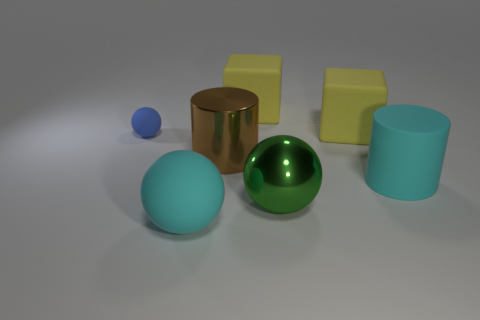The sphere that is right of the big cyan rubber thing in front of the large cyan matte cylinder is made of what material?
Your response must be concise. Metal. Is the green ball the same size as the cyan rubber sphere?
Ensure brevity in your answer.  Yes. How many objects are either large matte objects or matte spheres?
Keep it short and to the point. 5. There is a rubber object that is in front of the small blue rubber ball and on the right side of the large cyan ball; how big is it?
Ensure brevity in your answer.  Large. Is the number of big brown objects that are on the right side of the big metal ball less than the number of big cyan spheres?
Provide a short and direct response. Yes. What is the shape of the blue object that is the same material as the cyan cylinder?
Offer a terse response. Sphere. There is a metallic object that is on the right side of the brown thing; is it the same shape as the thing that is left of the cyan matte sphere?
Offer a terse response. Yes. Are there fewer big yellow blocks that are in front of the brown shiny object than large brown metallic cylinders on the right side of the shiny ball?
Make the answer very short. No. What shape is the big matte thing that is the same color as the matte cylinder?
Ensure brevity in your answer.  Sphere. What number of green things have the same size as the metallic cylinder?
Give a very brief answer. 1. 